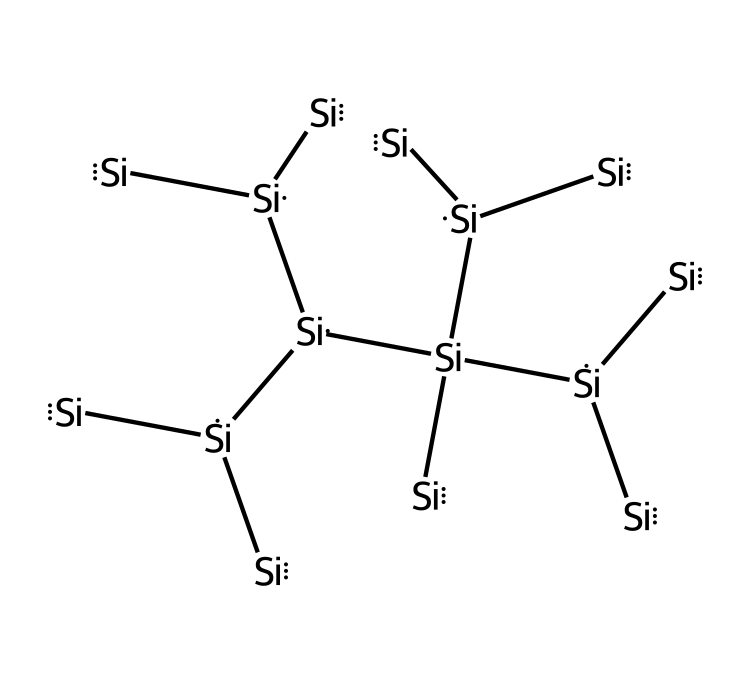What is the primary element represented in this structure? The SMILES representation shows a series of silicon (Si) atoms linked together, indicating that silicon is the primary element.
Answer: silicon How many silicon atoms are present in this structure? By counting the occurrences of the silicon symbol [Si] in the SMILES representation, we can see there are ten silicon atoms connected in a network.
Answer: ten What type of crystal structure do silicon wafers typically have? Silicon wafers commonly exhibit a diamond cubic crystal structure, which is characteristic of silicon's crystalline arrangement.
Answer: diamond cubic What property of silicon wafers makes them suitable for semiconductor applications? Silicon has a moderate band gap that allows it to effectively conduct electricity under certain conditions, making it ideal for semiconductor devices.
Answer: moderate band gap How many bonds are formed between each silicon atom in this structure? Each silicon atom typically forms four covalent bonds with neighboring silicon atoms, which can be inferred from the tetrahedral coordination in crystalline silicon.
Answer: four Why is the crystalline structure of silicon important for chip manufacturing? The orderly arrangement of silicon atoms allows for efficient electron flow and effective insulation, which are crucial for the performance of semiconductor devices in chip manufacturing.
Answer: efficient electron flow 